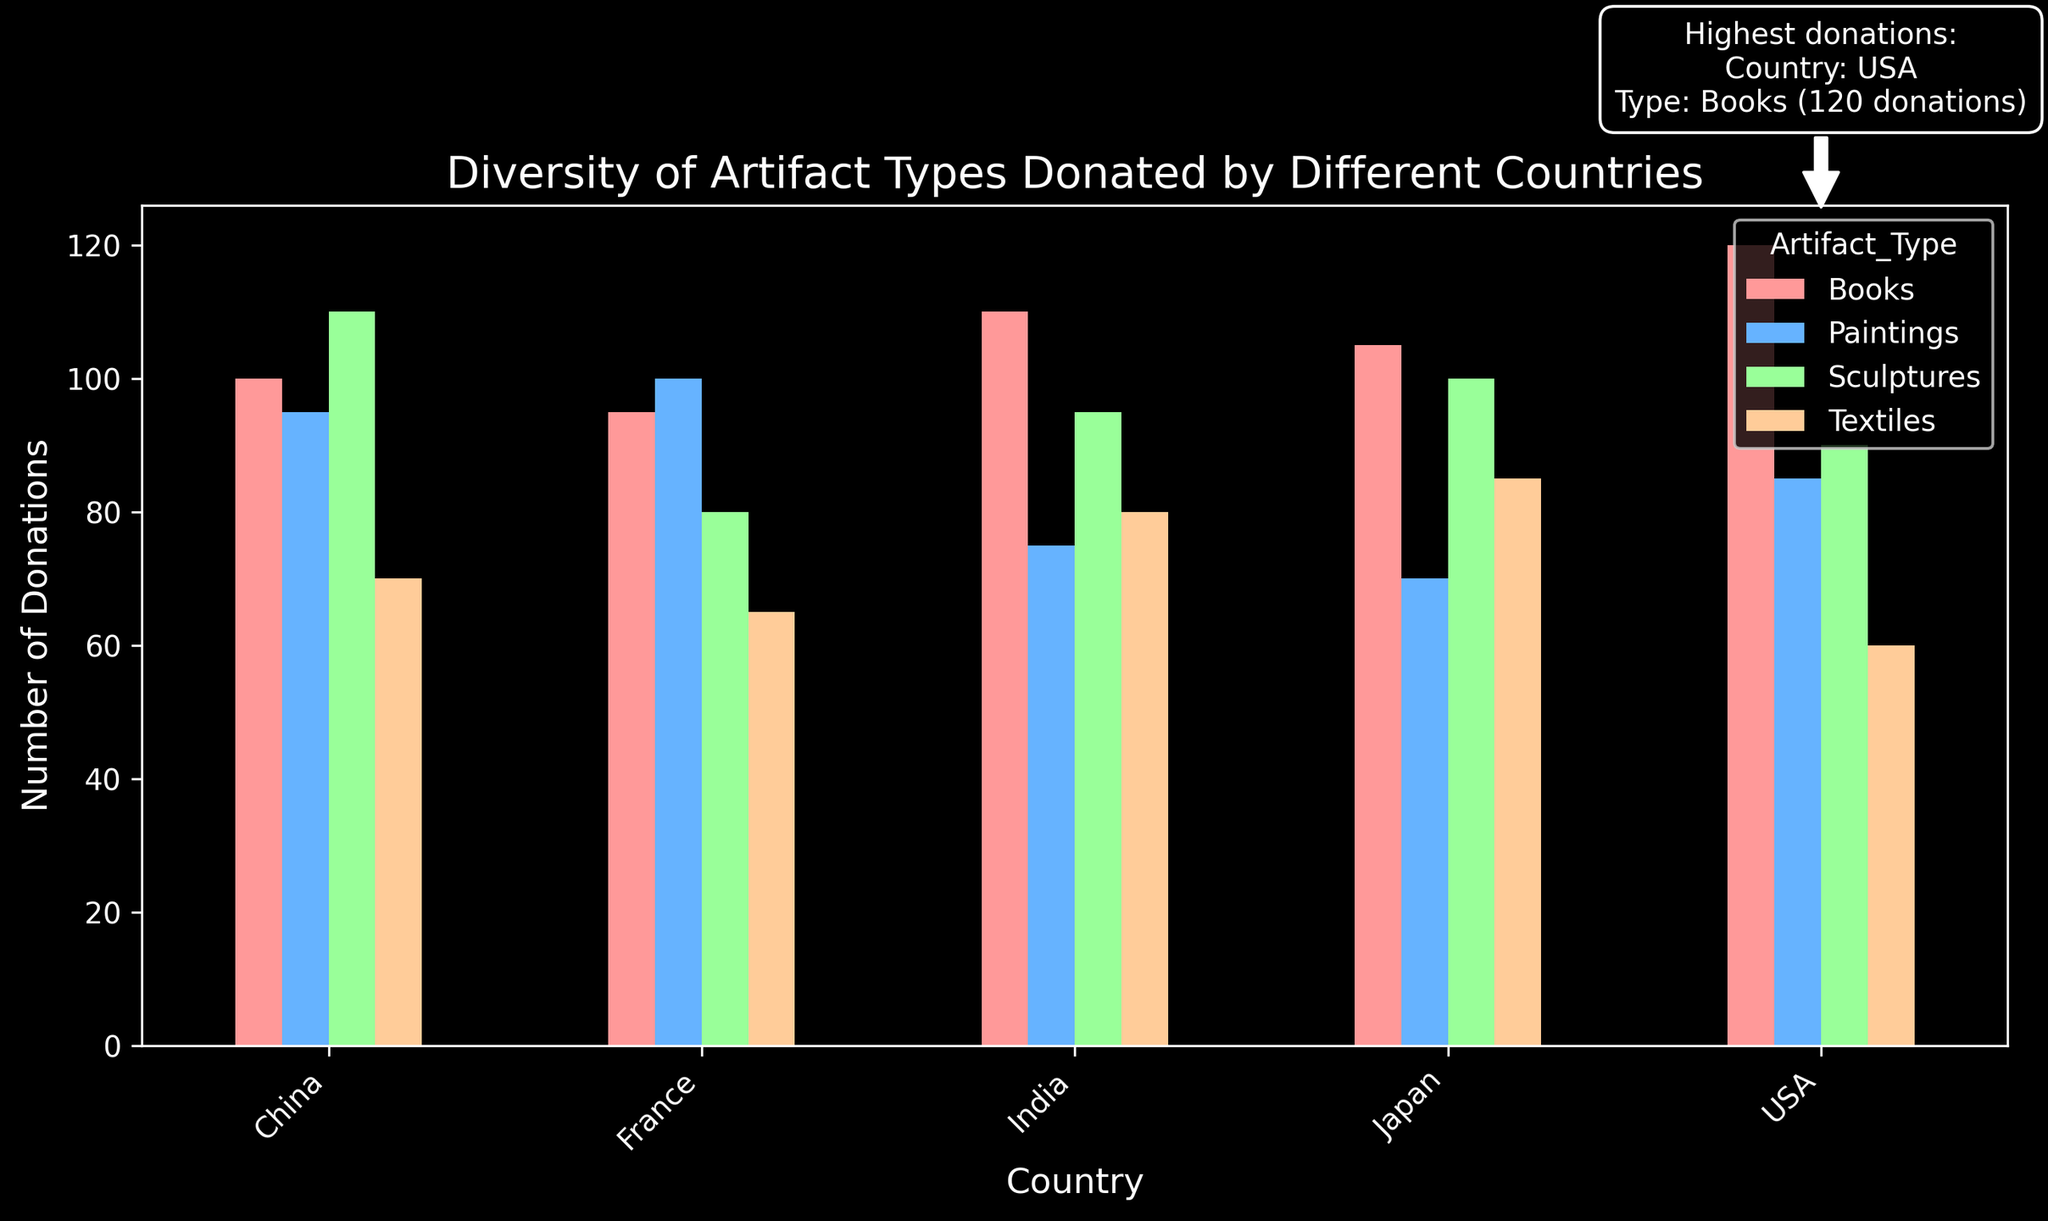What is the most donated type of artifact across all countries? The most donated type of artifact is Books, as suggested by both the visual representation showing the tallest bars for this category across multiple countries and the highlighted annotation on the chart.
Answer: Books Which country donated the highest number of books? The annotation on the chart highlights that the USA donated the highest number of books, with 120 donations. This is corroborated by the bar heights in the USA section.
Answer: USA How many more sculptures than textiles did China donate? To find this, subtract the number of textile donations from the number of sculpture donations for China. China's donations: Sculptures (110) - Textiles (70) = 40.
Answer: 40 Which country donated the fewest paintings? By visually comparing the heights of the bars for Paintings across all countries, Japan has the shortest bar in this category, indicating the fewest donations.
Answer: Japan What is the combined number of books donated by France and Japan? Add the number of book donations from both countries: France (95) + Japan (105) = 200.
Answer: 200 Is the number of textile donations greater in India or Japan? Compare the heights of the Textile bars for India and Japan. India's bar is slightly shorter than Japan's. Thus, Japan has more textile donations.
Answer: Japan What is the total number of artifacts donated by the USA? Sum the donations of all artifact types by the USA: Books (120) + Paintings (85) + Sculptures (90) + Textiles (60) = 355.
Answer: 355 Which country has the second-highest number of sculpture donations? By examining the bar heights for Sculptures, China has the highest, followed by Japan, which has the second-highest number.
Answer: Japan How many donations fewer did India make for paintings compared to sculptures? Subtract the number of painting donations from sculpture donations for India: Sculptures (95) - Paintings (75) = 20.
Answer: 20 How does the total number of donations compare between China and France? Sum the total donations for each country and compare: China (100 + 95 + 110 + 70 = 375), France (95 + 100 + 80 + 65 = 340). China has more donations.
Answer: China 